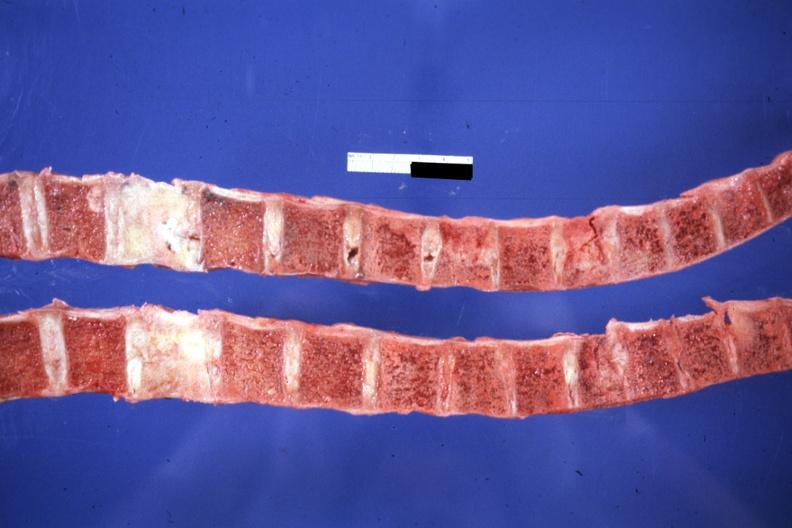s joints present?
Answer the question using a single word or phrase. Yes 